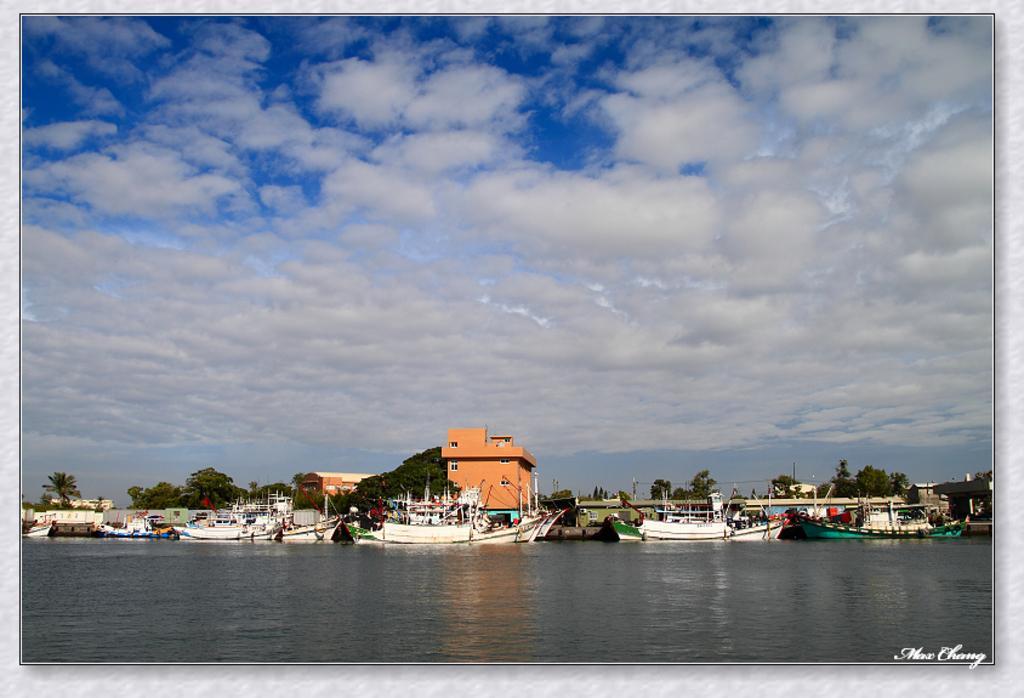Could you give a brief overview of what you see in this image? In the image there is a lake in the front with many boat on it and behind there are buildings and trees on the land and above its sky with clouds. 